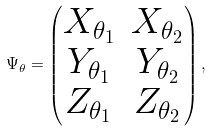<formula> <loc_0><loc_0><loc_500><loc_500>\Psi _ { \theta } = \begin{pmatrix} X _ { \theta _ { 1 } } & X _ { \theta _ { 2 } } \\ Y _ { \theta _ { 1 } } & Y _ { \theta _ { 2 } } \\ Z _ { \theta _ { 1 } } & Z _ { \theta _ { 2 } } \end{pmatrix} ,</formula> 